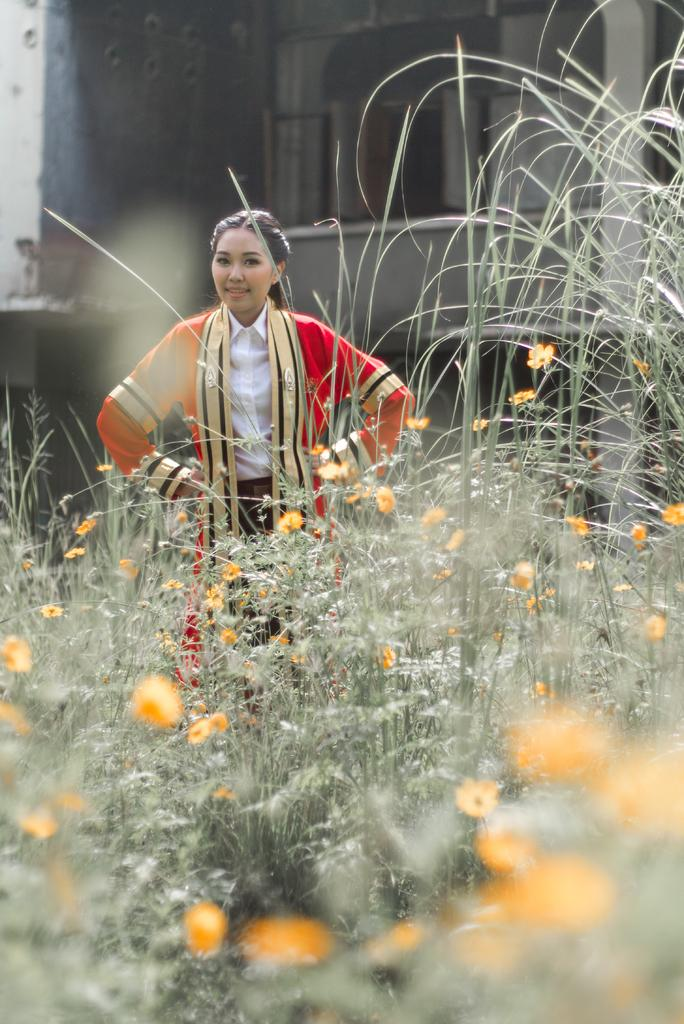What is the main subject of the image? There is a woman standing in the image. Where is the woman standing? The woman is standing on the ground. What type of vegetation can be seen in the image? Flowering plants are present in the image. What can be seen in the background of the image? There is a building and a door in the background of the image. When might this image have been taken? The image was likely taken during the day, as there is sufficient light to see the details. What type of pump can be seen in the image? There is no pump present in the image. Is there a basketball game happening in the background of the image? There is no basketball game or any reference to sports in the image. 